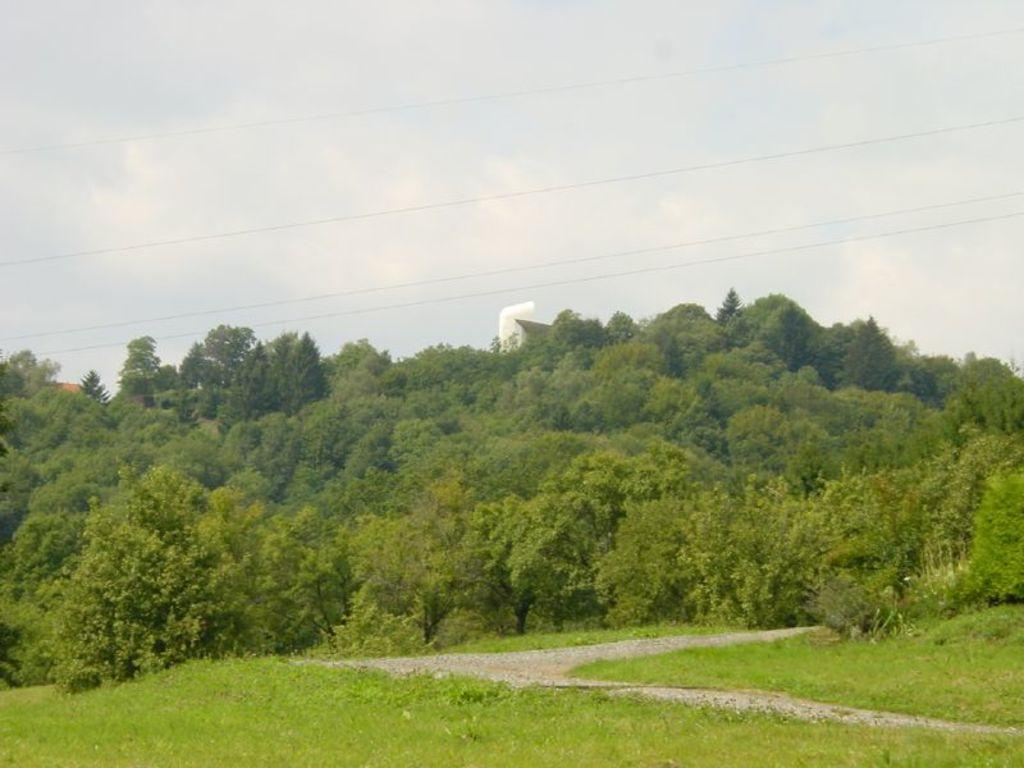What type of vegetation is present in the image? There is grass in the image. Are there any other plants visible in the image? Yes, there are trees in the image. What else can be seen in the image besides vegetation? There are wires in the image. What is visible in the background of the image? The sky is visible in the background of the image. What type of boot is hanging from the wires in the image? There is no boot present in the image; it only features grass, trees, wires, and the sky. What idea is being conveyed by the trees in the image? The trees in the image do not convey any specific idea; they are simply a part of the natural landscape. 